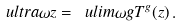Convert formula to latex. <formula><loc_0><loc_0><loc_500><loc_500>\ u l t r a { \omega } z = \ u l i m { \omega } { g } T ^ { g } ( z ) \, .</formula> 